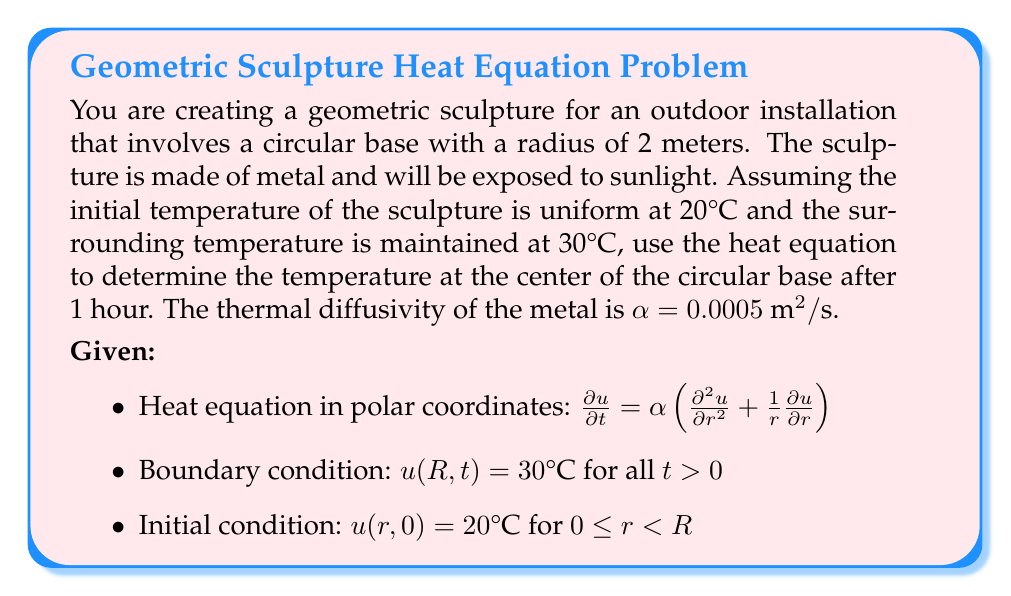Give your solution to this math problem. To solve this problem, we'll use the solution to the heat equation for a circular disk with a fixed boundary temperature:

1) The general solution is given by:

   $$u(r,t) = u_{\infty} + \sum_{n=1}^{\infty} A_n J_0\left(\frac{\lambda_n r}{R}\right) e^{-\alpha \lambda_n^2 t/R^2}$$

   where $u_{\infty}$ is the boundary temperature, $J_0$ is the Bessel function of the first kind of order zero, and $\lambda_n$ are the positive roots of $J_0(\lambda) = 0$.

2) The coefficients $A_n$ are determined by the initial condition:

   $$A_n = \frac{2}{R^2 J_1^2(\lambda_n)} \int_0^R r(u_0 - u_{\infty})J_0\left(\frac{\lambda_n r}{R}\right) dr$$

   where $u_0$ is the initial temperature.

3) For our case:
   $u_{\infty} = 30°\text{C}$
   $u_0 = 20°\text{C}$
   $R = 2 \text{ m}$
   $\alpha = 0.0005 \text{ m}^2/\text{s}$
   $t = 1 \text{ hour} = 3600 \text{ s}$

4) We're interested in the temperature at the center, so $r = 0$. Note that $J_0(0) = 1$.

5) The solution simplifies to:

   $$u(0,t) = 30 - 10 \sum_{n=1}^{\infty} \frac{2}{\lambda_n J_1(\lambda_n)} e^{-0.0005 \lambda_n^2 t/4}$$

6) Using the first few terms of the series (as higher terms quickly become negligible):

   $\lambda_1 \approx 2.4048$
   $\lambda_2 \approx 5.5201$
   $\lambda_3 \approx 8.6537$

7) Calculating:

   $$u(0,3600) \approx 30 - 10 \left(\frac{2}{2.4048 J_1(2.4048)} e^{-0.0005 \cdot 2.4048^2 \cdot 3600/4} + \frac{2}{5.5201 J_1(5.5201)} e^{-0.0005 \cdot 5.5201^2 \cdot 3600/4} + \frac{2}{8.6537 J_1(8.6537)} e^{-0.0005 \cdot 8.6537^2 \cdot 3600/4}\right)$$

8) Evaluating this expression numerically gives us approximately 29.93°C.
Answer: 29.93°C 